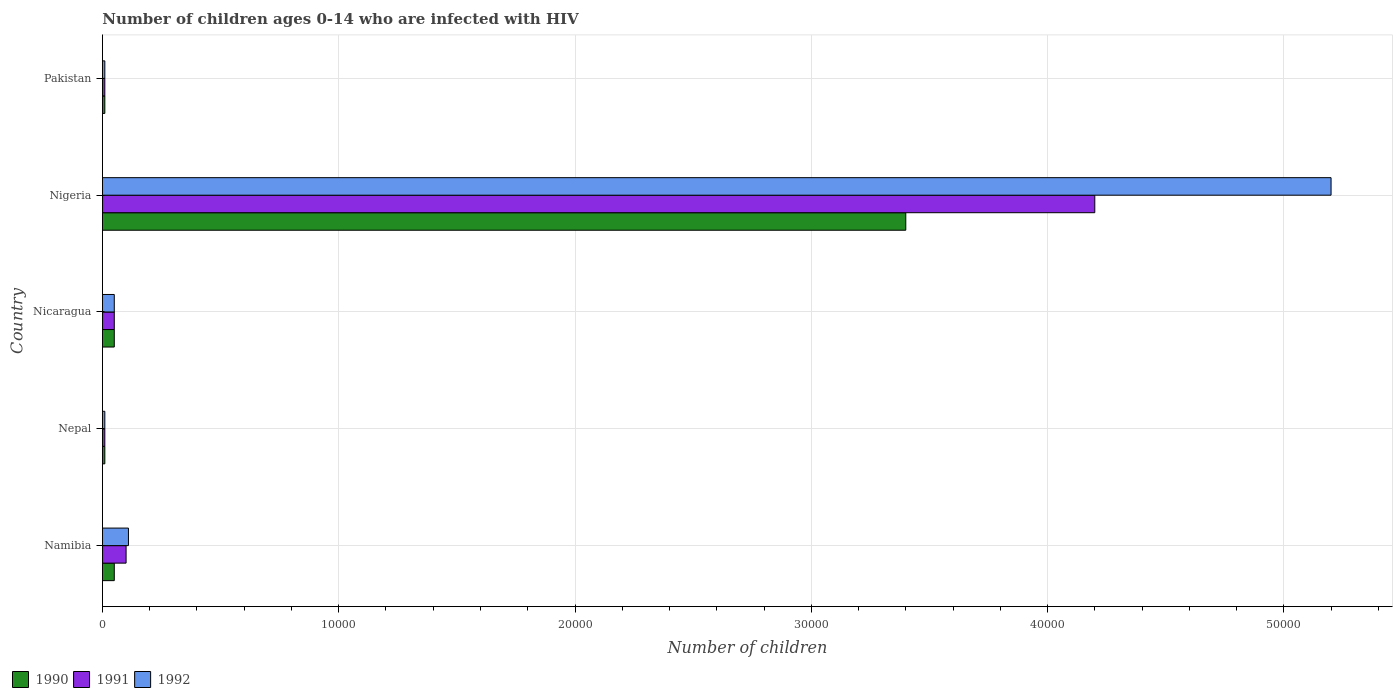How many groups of bars are there?
Your answer should be compact. 5. Are the number of bars per tick equal to the number of legend labels?
Keep it short and to the point. Yes. How many bars are there on the 1st tick from the top?
Offer a very short reply. 3. What is the label of the 3rd group of bars from the top?
Offer a terse response. Nicaragua. In how many cases, is the number of bars for a given country not equal to the number of legend labels?
Make the answer very short. 0. What is the number of HIV infected children in 1990 in Namibia?
Offer a terse response. 500. Across all countries, what is the maximum number of HIV infected children in 1990?
Give a very brief answer. 3.40e+04. Across all countries, what is the minimum number of HIV infected children in 1990?
Your answer should be very brief. 100. In which country was the number of HIV infected children in 1992 maximum?
Offer a very short reply. Nigeria. In which country was the number of HIV infected children in 1992 minimum?
Make the answer very short. Nepal. What is the total number of HIV infected children in 1990 in the graph?
Your answer should be compact. 3.52e+04. What is the difference between the number of HIV infected children in 1991 in Namibia and that in Nepal?
Provide a short and direct response. 900. What is the difference between the number of HIV infected children in 1991 in Nicaragua and the number of HIV infected children in 1990 in Nepal?
Your answer should be very brief. 400. What is the average number of HIV infected children in 1991 per country?
Provide a short and direct response. 8740. What is the difference between the number of HIV infected children in 1991 and number of HIV infected children in 1990 in Nicaragua?
Your answer should be compact. 0. What is the difference between the highest and the second highest number of HIV infected children in 1992?
Provide a succinct answer. 5.09e+04. What is the difference between the highest and the lowest number of HIV infected children in 1991?
Provide a succinct answer. 4.19e+04. In how many countries, is the number of HIV infected children in 1992 greater than the average number of HIV infected children in 1992 taken over all countries?
Provide a short and direct response. 1. What does the 1st bar from the top in Pakistan represents?
Provide a succinct answer. 1992. What does the 3rd bar from the bottom in Namibia represents?
Your answer should be compact. 1992. Is it the case that in every country, the sum of the number of HIV infected children in 1991 and number of HIV infected children in 1992 is greater than the number of HIV infected children in 1990?
Ensure brevity in your answer.  Yes. How many countries are there in the graph?
Your response must be concise. 5. What is the difference between two consecutive major ticks on the X-axis?
Your answer should be very brief. 10000. Does the graph contain grids?
Offer a terse response. Yes. Where does the legend appear in the graph?
Offer a terse response. Bottom left. How many legend labels are there?
Offer a very short reply. 3. How are the legend labels stacked?
Offer a very short reply. Horizontal. What is the title of the graph?
Provide a succinct answer. Number of children ages 0-14 who are infected with HIV. What is the label or title of the X-axis?
Offer a very short reply. Number of children. What is the label or title of the Y-axis?
Offer a terse response. Country. What is the Number of children of 1990 in Namibia?
Your response must be concise. 500. What is the Number of children of 1991 in Namibia?
Give a very brief answer. 1000. What is the Number of children of 1992 in Namibia?
Offer a very short reply. 1100. What is the Number of children in 1992 in Nepal?
Give a very brief answer. 100. What is the Number of children of 1991 in Nicaragua?
Make the answer very short. 500. What is the Number of children of 1992 in Nicaragua?
Your response must be concise. 500. What is the Number of children in 1990 in Nigeria?
Your response must be concise. 3.40e+04. What is the Number of children of 1991 in Nigeria?
Ensure brevity in your answer.  4.20e+04. What is the Number of children in 1992 in Nigeria?
Keep it short and to the point. 5.20e+04. What is the Number of children in 1990 in Pakistan?
Ensure brevity in your answer.  100. Across all countries, what is the maximum Number of children of 1990?
Give a very brief answer. 3.40e+04. Across all countries, what is the maximum Number of children of 1991?
Offer a very short reply. 4.20e+04. Across all countries, what is the maximum Number of children of 1992?
Your response must be concise. 5.20e+04. Across all countries, what is the minimum Number of children of 1991?
Make the answer very short. 100. What is the total Number of children of 1990 in the graph?
Offer a terse response. 3.52e+04. What is the total Number of children of 1991 in the graph?
Make the answer very short. 4.37e+04. What is the total Number of children in 1992 in the graph?
Your response must be concise. 5.38e+04. What is the difference between the Number of children in 1990 in Namibia and that in Nepal?
Give a very brief answer. 400. What is the difference between the Number of children of 1991 in Namibia and that in Nepal?
Ensure brevity in your answer.  900. What is the difference between the Number of children in 1992 in Namibia and that in Nepal?
Keep it short and to the point. 1000. What is the difference between the Number of children of 1992 in Namibia and that in Nicaragua?
Offer a very short reply. 600. What is the difference between the Number of children of 1990 in Namibia and that in Nigeria?
Your answer should be compact. -3.35e+04. What is the difference between the Number of children in 1991 in Namibia and that in Nigeria?
Ensure brevity in your answer.  -4.10e+04. What is the difference between the Number of children of 1992 in Namibia and that in Nigeria?
Make the answer very short. -5.09e+04. What is the difference between the Number of children of 1990 in Namibia and that in Pakistan?
Your answer should be very brief. 400. What is the difference between the Number of children of 1991 in Namibia and that in Pakistan?
Offer a terse response. 900. What is the difference between the Number of children of 1990 in Nepal and that in Nicaragua?
Ensure brevity in your answer.  -400. What is the difference between the Number of children in 1991 in Nepal and that in Nicaragua?
Your response must be concise. -400. What is the difference between the Number of children in 1992 in Nepal and that in Nicaragua?
Your response must be concise. -400. What is the difference between the Number of children in 1990 in Nepal and that in Nigeria?
Keep it short and to the point. -3.39e+04. What is the difference between the Number of children of 1991 in Nepal and that in Nigeria?
Your response must be concise. -4.19e+04. What is the difference between the Number of children of 1992 in Nepal and that in Nigeria?
Your answer should be very brief. -5.19e+04. What is the difference between the Number of children of 1990 in Nepal and that in Pakistan?
Ensure brevity in your answer.  0. What is the difference between the Number of children of 1991 in Nepal and that in Pakistan?
Your answer should be very brief. 0. What is the difference between the Number of children in 1992 in Nepal and that in Pakistan?
Offer a terse response. 0. What is the difference between the Number of children in 1990 in Nicaragua and that in Nigeria?
Ensure brevity in your answer.  -3.35e+04. What is the difference between the Number of children of 1991 in Nicaragua and that in Nigeria?
Your answer should be very brief. -4.15e+04. What is the difference between the Number of children of 1992 in Nicaragua and that in Nigeria?
Make the answer very short. -5.15e+04. What is the difference between the Number of children in 1992 in Nicaragua and that in Pakistan?
Provide a succinct answer. 400. What is the difference between the Number of children in 1990 in Nigeria and that in Pakistan?
Provide a succinct answer. 3.39e+04. What is the difference between the Number of children of 1991 in Nigeria and that in Pakistan?
Ensure brevity in your answer.  4.19e+04. What is the difference between the Number of children in 1992 in Nigeria and that in Pakistan?
Your answer should be compact. 5.19e+04. What is the difference between the Number of children of 1991 in Namibia and the Number of children of 1992 in Nepal?
Provide a succinct answer. 900. What is the difference between the Number of children in 1990 in Namibia and the Number of children in 1991 in Nicaragua?
Provide a succinct answer. 0. What is the difference between the Number of children in 1990 in Namibia and the Number of children in 1991 in Nigeria?
Keep it short and to the point. -4.15e+04. What is the difference between the Number of children of 1990 in Namibia and the Number of children of 1992 in Nigeria?
Make the answer very short. -5.15e+04. What is the difference between the Number of children in 1991 in Namibia and the Number of children in 1992 in Nigeria?
Ensure brevity in your answer.  -5.10e+04. What is the difference between the Number of children in 1990 in Namibia and the Number of children in 1991 in Pakistan?
Offer a terse response. 400. What is the difference between the Number of children of 1990 in Namibia and the Number of children of 1992 in Pakistan?
Make the answer very short. 400. What is the difference between the Number of children in 1991 in Namibia and the Number of children in 1992 in Pakistan?
Keep it short and to the point. 900. What is the difference between the Number of children in 1990 in Nepal and the Number of children in 1991 in Nicaragua?
Offer a terse response. -400. What is the difference between the Number of children in 1990 in Nepal and the Number of children in 1992 in Nicaragua?
Your answer should be compact. -400. What is the difference between the Number of children in 1991 in Nepal and the Number of children in 1992 in Nicaragua?
Make the answer very short. -400. What is the difference between the Number of children of 1990 in Nepal and the Number of children of 1991 in Nigeria?
Your response must be concise. -4.19e+04. What is the difference between the Number of children in 1990 in Nepal and the Number of children in 1992 in Nigeria?
Provide a short and direct response. -5.19e+04. What is the difference between the Number of children of 1991 in Nepal and the Number of children of 1992 in Nigeria?
Give a very brief answer. -5.19e+04. What is the difference between the Number of children of 1990 in Nepal and the Number of children of 1992 in Pakistan?
Provide a succinct answer. 0. What is the difference between the Number of children in 1990 in Nicaragua and the Number of children in 1991 in Nigeria?
Give a very brief answer. -4.15e+04. What is the difference between the Number of children of 1990 in Nicaragua and the Number of children of 1992 in Nigeria?
Keep it short and to the point. -5.15e+04. What is the difference between the Number of children of 1991 in Nicaragua and the Number of children of 1992 in Nigeria?
Make the answer very short. -5.15e+04. What is the difference between the Number of children in 1990 in Nicaragua and the Number of children in 1991 in Pakistan?
Offer a very short reply. 400. What is the difference between the Number of children of 1990 in Nicaragua and the Number of children of 1992 in Pakistan?
Offer a terse response. 400. What is the difference between the Number of children in 1991 in Nicaragua and the Number of children in 1992 in Pakistan?
Your response must be concise. 400. What is the difference between the Number of children of 1990 in Nigeria and the Number of children of 1991 in Pakistan?
Make the answer very short. 3.39e+04. What is the difference between the Number of children of 1990 in Nigeria and the Number of children of 1992 in Pakistan?
Your response must be concise. 3.39e+04. What is the difference between the Number of children in 1991 in Nigeria and the Number of children in 1992 in Pakistan?
Your answer should be compact. 4.19e+04. What is the average Number of children of 1990 per country?
Your answer should be very brief. 7040. What is the average Number of children in 1991 per country?
Keep it short and to the point. 8740. What is the average Number of children in 1992 per country?
Your answer should be compact. 1.08e+04. What is the difference between the Number of children in 1990 and Number of children in 1991 in Namibia?
Your answer should be very brief. -500. What is the difference between the Number of children in 1990 and Number of children in 1992 in Namibia?
Offer a very short reply. -600. What is the difference between the Number of children of 1991 and Number of children of 1992 in Namibia?
Make the answer very short. -100. What is the difference between the Number of children of 1990 and Number of children of 1992 in Nepal?
Provide a short and direct response. 0. What is the difference between the Number of children in 1991 and Number of children in 1992 in Nepal?
Keep it short and to the point. 0. What is the difference between the Number of children of 1990 and Number of children of 1992 in Nicaragua?
Keep it short and to the point. 0. What is the difference between the Number of children in 1991 and Number of children in 1992 in Nicaragua?
Offer a very short reply. 0. What is the difference between the Number of children of 1990 and Number of children of 1991 in Nigeria?
Make the answer very short. -8000. What is the difference between the Number of children in 1990 and Number of children in 1992 in Nigeria?
Make the answer very short. -1.80e+04. What is the difference between the Number of children in 1990 and Number of children in 1991 in Pakistan?
Make the answer very short. 0. What is the difference between the Number of children in 1990 and Number of children in 1992 in Pakistan?
Offer a very short reply. 0. What is the difference between the Number of children in 1991 and Number of children in 1992 in Pakistan?
Make the answer very short. 0. What is the ratio of the Number of children of 1990 in Namibia to that in Nepal?
Offer a very short reply. 5. What is the ratio of the Number of children in 1991 in Namibia to that in Nepal?
Give a very brief answer. 10. What is the ratio of the Number of children in 1990 in Namibia to that in Nigeria?
Give a very brief answer. 0.01. What is the ratio of the Number of children in 1991 in Namibia to that in Nigeria?
Your answer should be compact. 0.02. What is the ratio of the Number of children of 1992 in Namibia to that in Nigeria?
Offer a very short reply. 0.02. What is the ratio of the Number of children in 1990 in Nepal to that in Nicaragua?
Your answer should be very brief. 0.2. What is the ratio of the Number of children in 1992 in Nepal to that in Nicaragua?
Keep it short and to the point. 0.2. What is the ratio of the Number of children of 1990 in Nepal to that in Nigeria?
Offer a very short reply. 0. What is the ratio of the Number of children in 1991 in Nepal to that in Nigeria?
Provide a succinct answer. 0. What is the ratio of the Number of children in 1992 in Nepal to that in Nigeria?
Give a very brief answer. 0. What is the ratio of the Number of children of 1990 in Nepal to that in Pakistan?
Offer a terse response. 1. What is the ratio of the Number of children in 1991 in Nepal to that in Pakistan?
Keep it short and to the point. 1. What is the ratio of the Number of children of 1990 in Nicaragua to that in Nigeria?
Your response must be concise. 0.01. What is the ratio of the Number of children of 1991 in Nicaragua to that in Nigeria?
Offer a very short reply. 0.01. What is the ratio of the Number of children of 1992 in Nicaragua to that in Nigeria?
Offer a terse response. 0.01. What is the ratio of the Number of children of 1992 in Nicaragua to that in Pakistan?
Give a very brief answer. 5. What is the ratio of the Number of children in 1990 in Nigeria to that in Pakistan?
Make the answer very short. 340. What is the ratio of the Number of children in 1991 in Nigeria to that in Pakistan?
Ensure brevity in your answer.  420. What is the ratio of the Number of children of 1992 in Nigeria to that in Pakistan?
Offer a very short reply. 520. What is the difference between the highest and the second highest Number of children of 1990?
Provide a short and direct response. 3.35e+04. What is the difference between the highest and the second highest Number of children of 1991?
Your response must be concise. 4.10e+04. What is the difference between the highest and the second highest Number of children of 1992?
Ensure brevity in your answer.  5.09e+04. What is the difference between the highest and the lowest Number of children of 1990?
Your answer should be compact. 3.39e+04. What is the difference between the highest and the lowest Number of children of 1991?
Provide a succinct answer. 4.19e+04. What is the difference between the highest and the lowest Number of children of 1992?
Provide a short and direct response. 5.19e+04. 